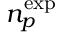Convert formula to latex. <formula><loc_0><loc_0><loc_500><loc_500>{ n _ { p } ^ { e x p } }</formula> 